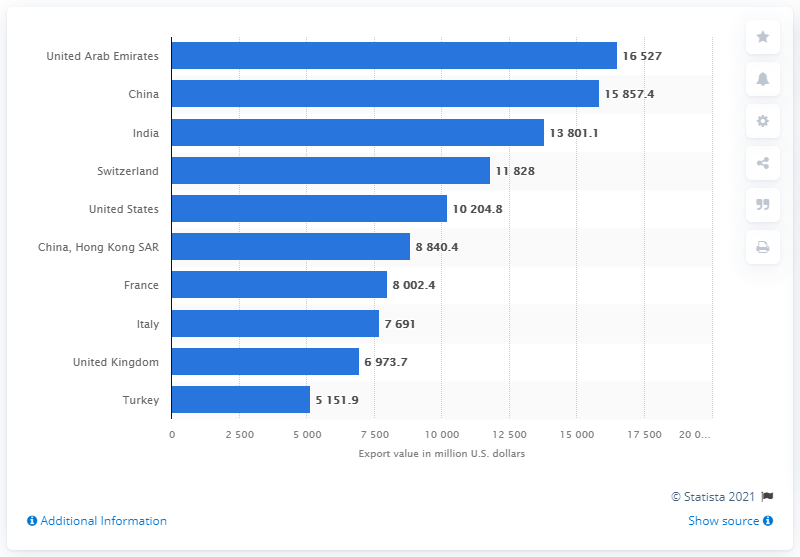Indicate a few pertinent items in this graphic. In 2019, China exported approximately 15,857.4 dollars' worth of goods to the United States. The value of the UAE's gold, silverware, and jewelry exports in 2019 was 16,527. 